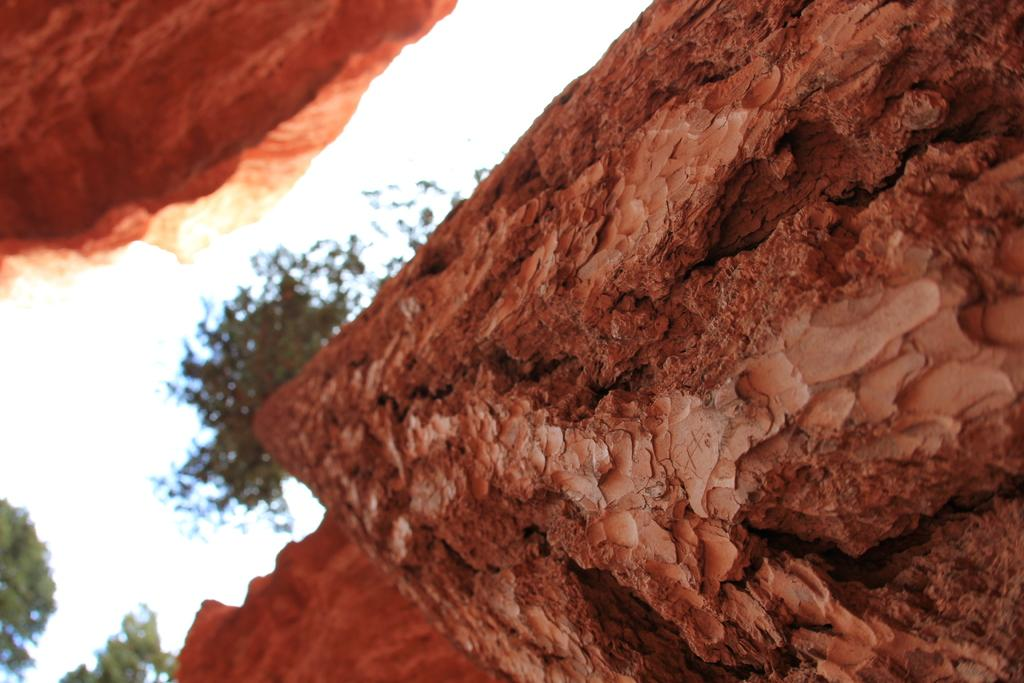What type of natural material is featured in the image? The image contains the bark of a tree. How many trees can be seen in the image? There are trees visible in the image. What part of the environment is visible in the image? The sky is visible in the image. What is the weather condition suggested by the appearance of the sky? The sky appears to be cloudy, suggesting a partly cloudy or overcast day. How many horses are present in the image? There are no horses visible in the image; it features the bark of a tree and trees in the background. What advice might the uncle in the image give about the tree bark? There is no uncle present in the image, so it is not possible to determine what advice he might give. 